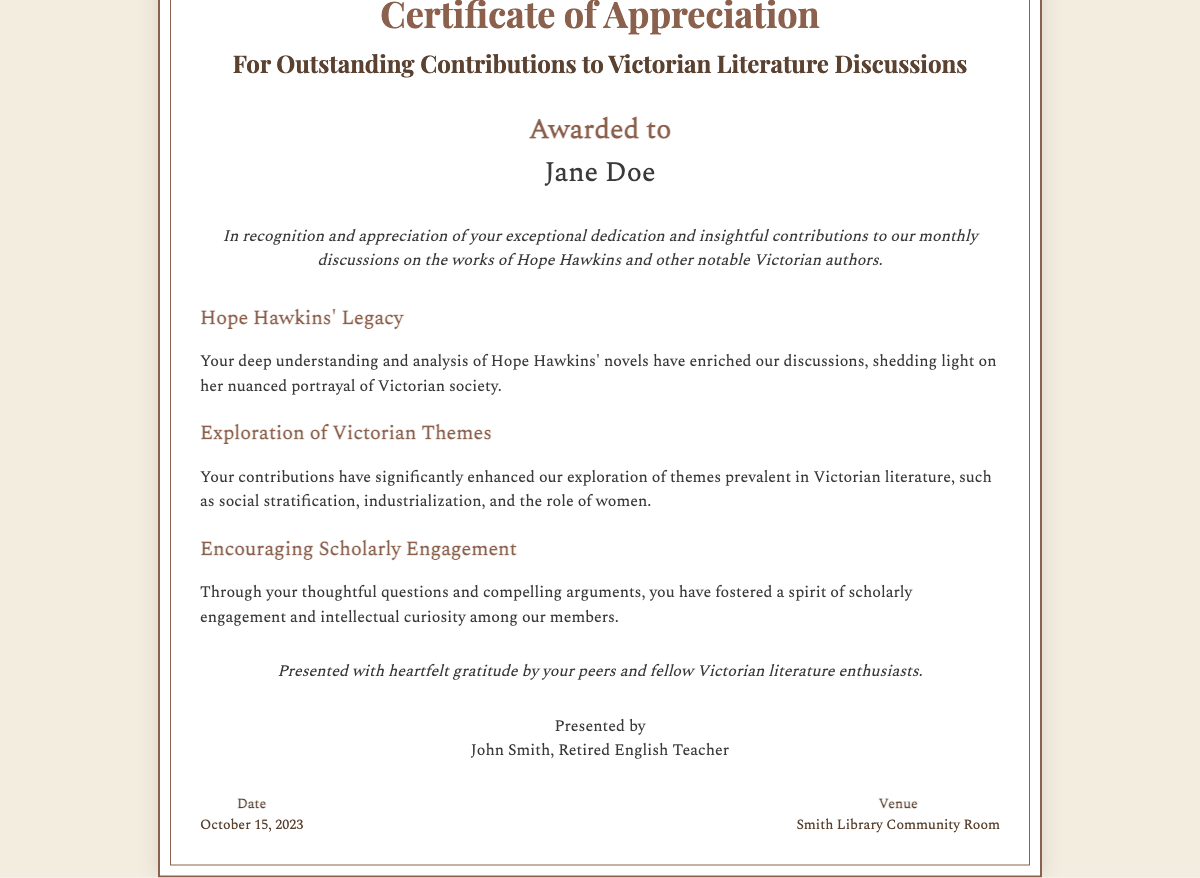What is the title of the certificate? The title of the certificate is displayed prominently at the top of the document.
Answer: Certificate of Appreciation Who is the certificate awarded to? The recipient's name is specified in the certificate's main content.
Answer: Jane Doe What is the date of presentation for this certificate? The date is provided in the footer of the document.
Answer: October 15, 2023 Who presented the certificate? The presenter's name is indicated in the organizer section of the document.
Answer: John Smith Where was the certificate presented? The venue is mentioned in the footer of the document.
Answer: Smith Library Community Room What is the main theme of the contributions recognized by the certificate? The certificate highlights the contributions to discussions on specific literary themes.
Answer: Victorian Literature Discussions What has the recipient encouraged among fellow members? The certificate notes the type of engagement fostered by the recipient.
Answer: Scholarly Engagement What style is used for the introductory statement? The document's design includes a specific style for the introductory statement.
Answer: Italic What role does Hope Hawkins play in this document? The recipient's contributions specifically relate to this author's work.
Answer: Author of discussed works 